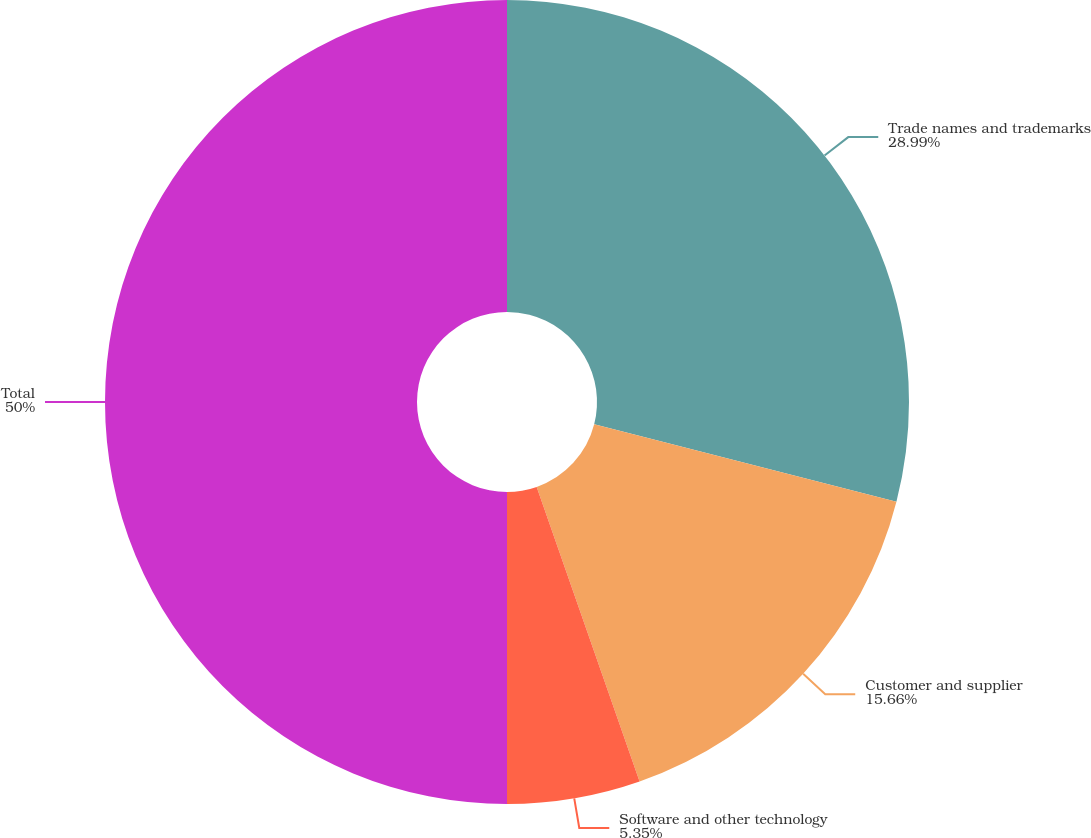Convert chart. <chart><loc_0><loc_0><loc_500><loc_500><pie_chart><fcel>Trade names and trademarks<fcel>Customer and supplier<fcel>Software and other technology<fcel>Total<nl><fcel>28.99%<fcel>15.66%<fcel>5.35%<fcel>50.0%<nl></chart> 